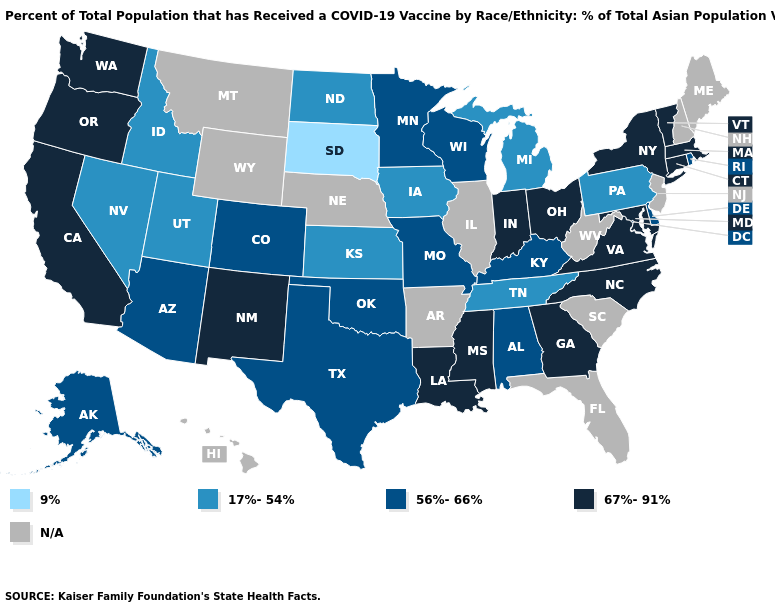Among the states that border Montana , does South Dakota have the lowest value?
Concise answer only. Yes. Which states have the highest value in the USA?
Keep it brief. California, Connecticut, Georgia, Indiana, Louisiana, Maryland, Massachusetts, Mississippi, New Mexico, New York, North Carolina, Ohio, Oregon, Vermont, Virginia, Washington. What is the value of Utah?
Concise answer only. 17%-54%. Among the states that border Virginia , which have the highest value?
Write a very short answer. Maryland, North Carolina. Does Missouri have the highest value in the MidWest?
Write a very short answer. No. Name the states that have a value in the range 9%?
Keep it brief. South Dakota. What is the value of Iowa?
Write a very short answer. 17%-54%. What is the highest value in states that border Nebraska?
Short answer required. 56%-66%. What is the lowest value in the West?
Keep it brief. 17%-54%. Is the legend a continuous bar?
Write a very short answer. No. Is the legend a continuous bar?
Short answer required. No. Is the legend a continuous bar?
Answer briefly. No. Is the legend a continuous bar?
Be succinct. No. What is the value of Maine?
Concise answer only. N/A. 